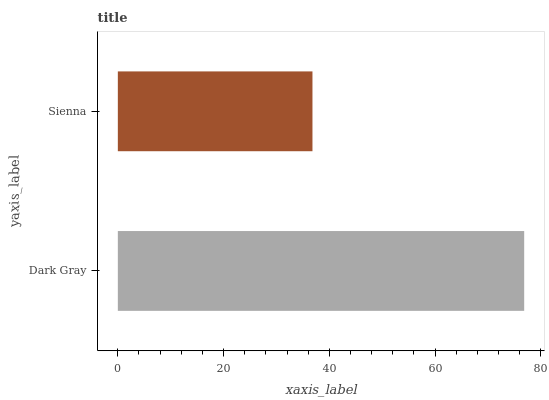Is Sienna the minimum?
Answer yes or no. Yes. Is Dark Gray the maximum?
Answer yes or no. Yes. Is Sienna the maximum?
Answer yes or no. No. Is Dark Gray greater than Sienna?
Answer yes or no. Yes. Is Sienna less than Dark Gray?
Answer yes or no. Yes. Is Sienna greater than Dark Gray?
Answer yes or no. No. Is Dark Gray less than Sienna?
Answer yes or no. No. Is Dark Gray the high median?
Answer yes or no. Yes. Is Sienna the low median?
Answer yes or no. Yes. Is Sienna the high median?
Answer yes or no. No. Is Dark Gray the low median?
Answer yes or no. No. 